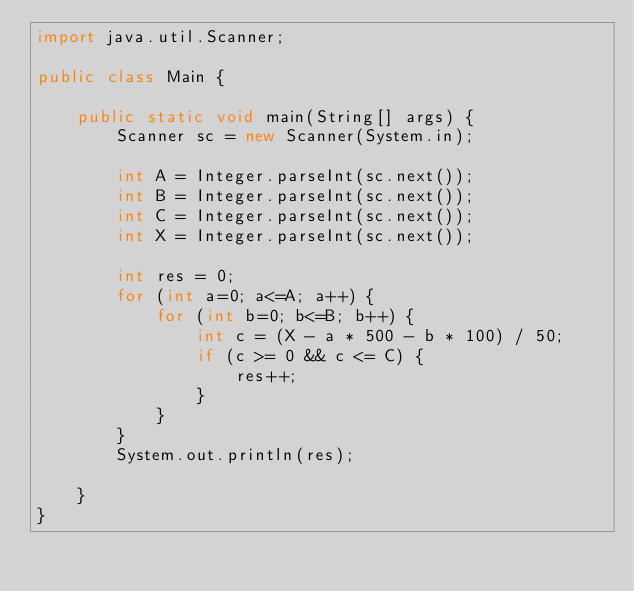<code> <loc_0><loc_0><loc_500><loc_500><_Java_>import java.util.Scanner;

public class Main {

    public static void main(String[] args) {
        Scanner sc = new Scanner(System.in);

        int A = Integer.parseInt(sc.next());
        int B = Integer.parseInt(sc.next());
        int C = Integer.parseInt(sc.next());
        int X = Integer.parseInt(sc.next());

        int res = 0;
        for (int a=0; a<=A; a++) {
            for (int b=0; b<=B; b++) {
                int c = (X - a * 500 - b * 100) / 50;
                if (c >= 0 && c <= C) {
                    res++;
                }
            }
        }
        System.out.println(res);

    }
}
</code> 